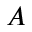Convert formula to latex. <formula><loc_0><loc_0><loc_500><loc_500>A</formula> 